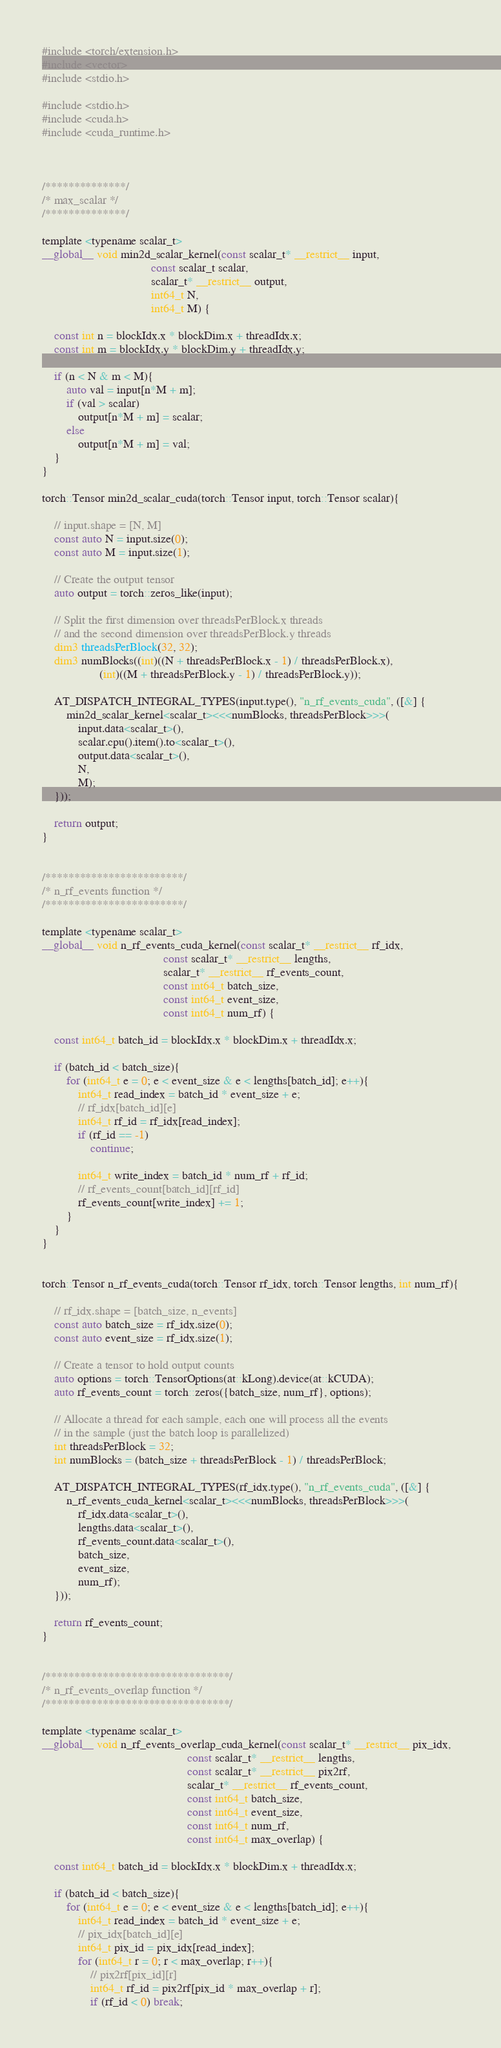Convert code to text. <code><loc_0><loc_0><loc_500><loc_500><_Cuda_>#include <torch/extension.h>
#include <vector>
#include <stdio.h>

#include <stdio.h>
#include <cuda.h>
#include <cuda_runtime.h>



/**************/
/* max_scalar */
/**************/

template <typename scalar_t>
__global__ void min2d_scalar_kernel(const scalar_t* __restrict__ input,
                                    const scalar_t scalar,
                                    scalar_t* __restrict__ output,
                                    int64_t N,
                                    int64_t M) {

    const int n = blockIdx.x * blockDim.x + threadIdx.x;
    const int m = blockIdx.y * blockDim.y + threadIdx.y;

    if (n < N & m < M){
        auto val = input[n*M + m];
        if (val > scalar)
            output[n*M + m] = scalar;
        else
            output[n*M + m] = val;
    }
}

torch::Tensor min2d_scalar_cuda(torch::Tensor input, torch::Tensor scalar){

    // input.shape = [N, M]
	const auto N = input.size(0);
	const auto M = input.size(1);

    // Create the output tensor
    auto output = torch::zeros_like(input);

    // Split the first dimension over threadsPerBlock.x threads
    // and the second dimension over threadsPerBlock.y threads
    dim3 threadsPerBlock(32, 32);
    dim3 numBlocks((int)((N + threadsPerBlock.x - 1) / threadsPerBlock.x),
                   (int)((M + threadsPerBlock.y - 1) / threadsPerBlock.y));

    AT_DISPATCH_INTEGRAL_TYPES(input.type(), "n_rf_events_cuda", ([&] {
		min2d_scalar_kernel<scalar_t><<<numBlocks, threadsPerBlock>>>(
			input.data<scalar_t>(),
			scalar.cpu().item().to<scalar_t>(),
			output.data<scalar_t>(),
			N,
			M);
	}));

    return output;
}


/************************/
/* n_rf_events function */
/************************/

template <typename scalar_t>
__global__ void n_rf_events_cuda_kernel(const scalar_t* __restrict__ rf_idx,
                                        const scalar_t* __restrict__ lengths,
										scalar_t* __restrict__ rf_events_count,
										const int64_t batch_size,
										const int64_t event_size,
										const int64_t num_rf) {

    const int64_t batch_id = blockIdx.x * blockDim.x + threadIdx.x;

    if (batch_id < batch_size){
        for (int64_t e = 0; e < event_size & e < lengths[batch_id]; e++){
            int64_t read_index = batch_id * event_size + e;
            // rf_idx[batch_id][e]
            int64_t rf_id = rf_idx[read_index];
            if (rf_id == -1)
                continue;

            int64_t write_index = batch_id * num_rf + rf_id;
            // rf_events_count[batch_id][rf_id]
            rf_events_count[write_index] += 1;
        }
    }
}


torch::Tensor n_rf_events_cuda(torch::Tensor rf_idx, torch::Tensor lengths, int num_rf){

	// rf_idx.shape = [batch_size, n_events]
	const auto batch_size = rf_idx.size(0);
	const auto event_size = rf_idx.size(1);

	// Create a tensor to hold output counts
	auto options = torch::TensorOptions(at::kLong).device(at::kCUDA);
	auto rf_events_count = torch::zeros({batch_size, num_rf}, options);

    // Allocate a thread for each sample, each one will process all the events
    // in the sample (just the batch loop is parallelized)
	int threadsPerBlock = 32;
	int numBlocks = (batch_size + threadsPerBlock - 1) / threadsPerBlock;

	AT_DISPATCH_INTEGRAL_TYPES(rf_idx.type(), "n_rf_events_cuda", ([&] {
		n_rf_events_cuda_kernel<scalar_t><<<numBlocks, threadsPerBlock>>>(
			rf_idx.data<scalar_t>(),
			lengths.data<scalar_t>(),
			rf_events_count.data<scalar_t>(),
			batch_size,
			event_size,
			num_rf);
	}));

	return rf_events_count;
}


/********************************/
/* n_rf_events_overlap function */
/********************************/

template <typename scalar_t>
__global__ void n_rf_events_overlap_cuda_kernel(const scalar_t* __restrict__ pix_idx,
                                                const scalar_t* __restrict__ lengths,
                                                const scalar_t* __restrict__ pix2rf,
                                                scalar_t* __restrict__ rf_events_count,
                                                const int64_t batch_size,
                                                const int64_t event_size,
                                                const int64_t num_rf,
                                                const int64_t max_overlap) {

    const int64_t batch_id = blockIdx.x * blockDim.x + threadIdx.x;

    if (batch_id < batch_size){
        for (int64_t e = 0; e < event_size & e < lengths[batch_id]; e++){
            int64_t read_index = batch_id * event_size + e;
            // pix_idx[batch_id][e]
            int64_t pix_id = pix_idx[read_index];
            for (int64_t r = 0; r < max_overlap; r++){
                // pix2rf[pix_id][r]
                int64_t rf_id = pix2rf[pix_id * max_overlap + r];
                if (rf_id < 0) break;
</code> 